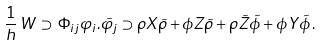Convert formula to latex. <formula><loc_0><loc_0><loc_500><loc_500>\frac { 1 } { h } \, W \, \supset \, \Phi _ { i j } \varphi _ { i } . \tilde { \varphi _ { j } } \supset \rho X \tilde { \rho } + \phi Z \tilde { \rho } + \rho \tilde { Z } \tilde { \phi } + \phi Y \tilde { \phi } \, .</formula> 